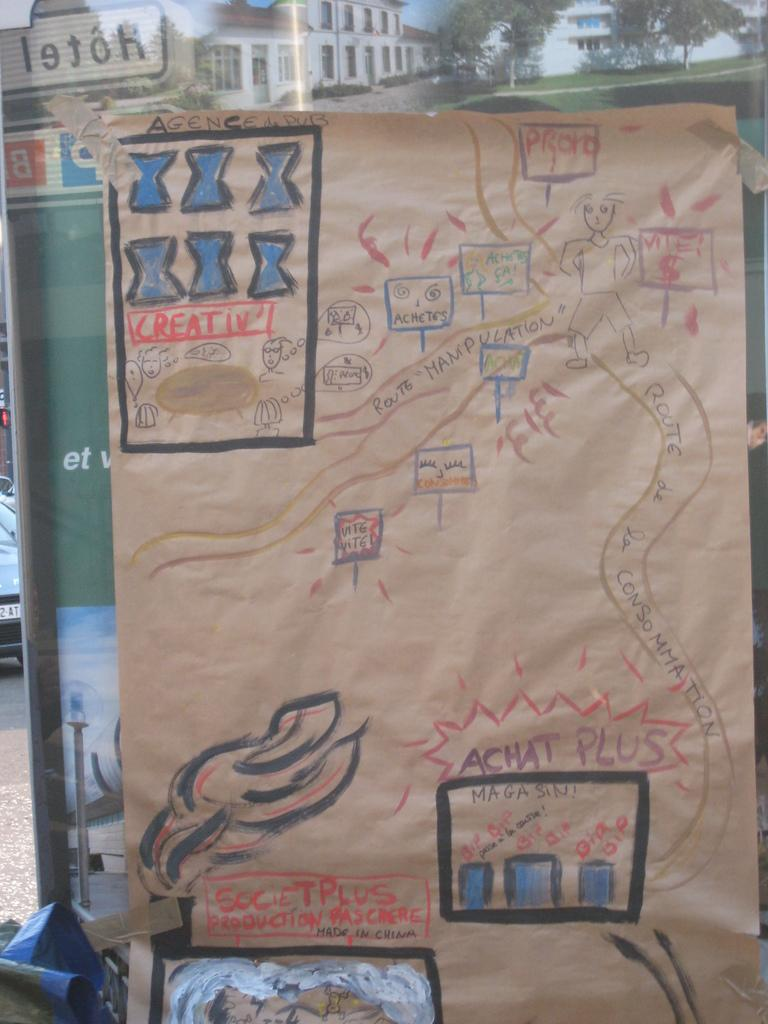Provide a one-sentence caption for the provided image. Map drawn by a child for Agence de Pub. 